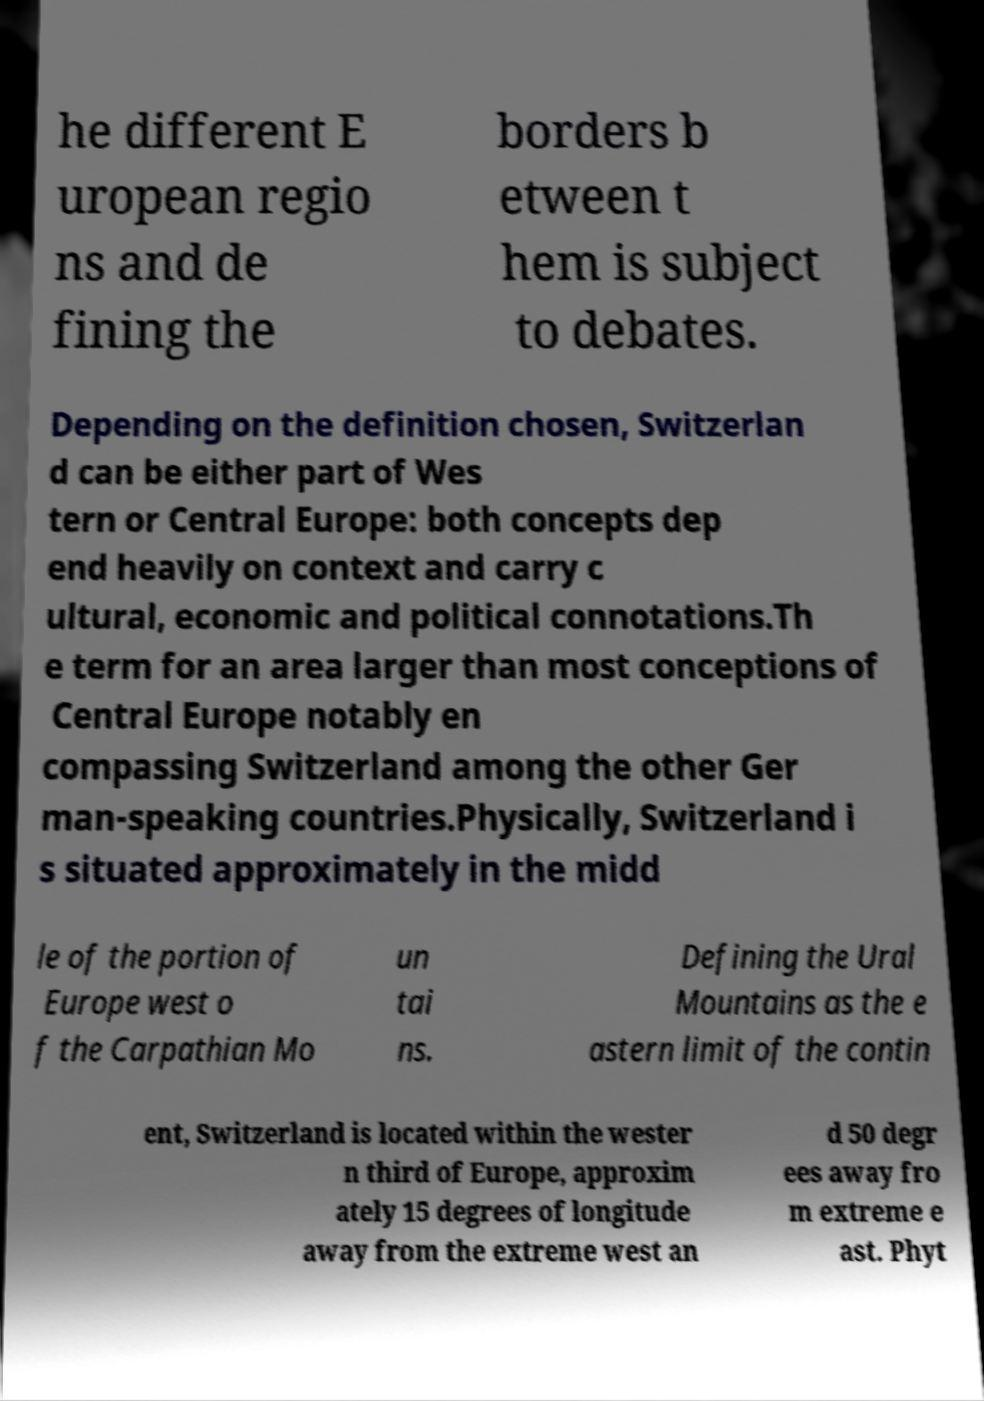Could you assist in decoding the text presented in this image and type it out clearly? he different E uropean regio ns and de fining the borders b etween t hem is subject to debates. Depending on the definition chosen, Switzerlan d can be either part of Wes tern or Central Europe: both concepts dep end heavily on context and carry c ultural, economic and political connotations.Th e term for an area larger than most conceptions of Central Europe notably en compassing Switzerland among the other Ger man-speaking countries.Physically, Switzerland i s situated approximately in the midd le of the portion of Europe west o f the Carpathian Mo un tai ns. Defining the Ural Mountains as the e astern limit of the contin ent, Switzerland is located within the wester n third of Europe, approxim ately 15 degrees of longitude away from the extreme west an d 50 degr ees away fro m extreme e ast. Phyt 